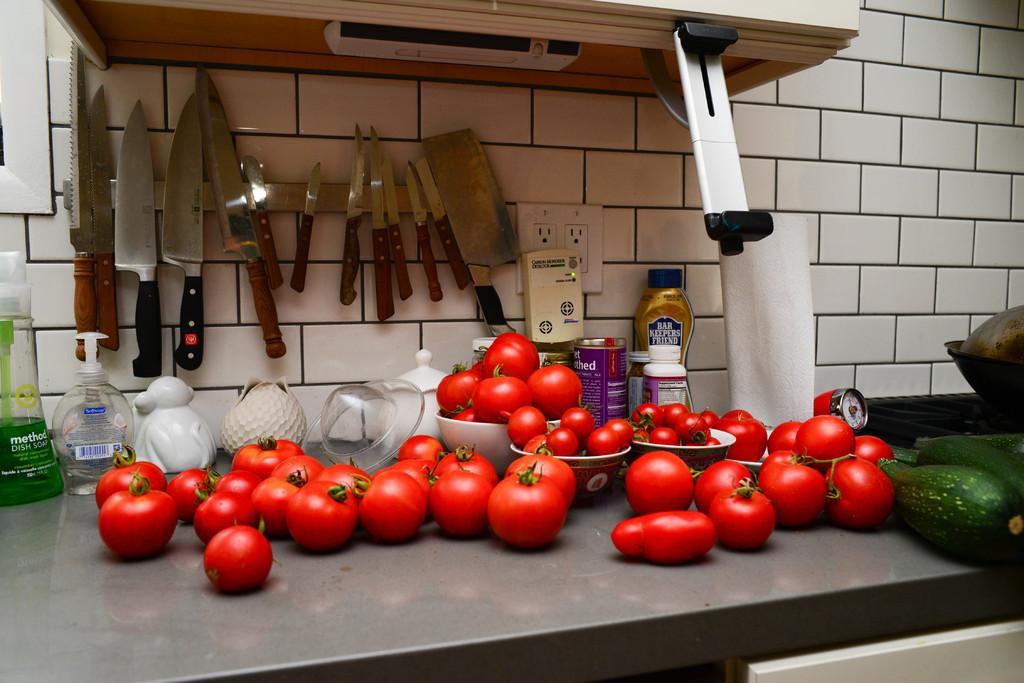Please provide a concise description of this image. In the foreground of the picture there is a table, on the table there are tomatoes, bowls, pots, bottles, hand wash, vegetables and other objects. In the center of the picture there are knives. At the top there is a microwave oven. 